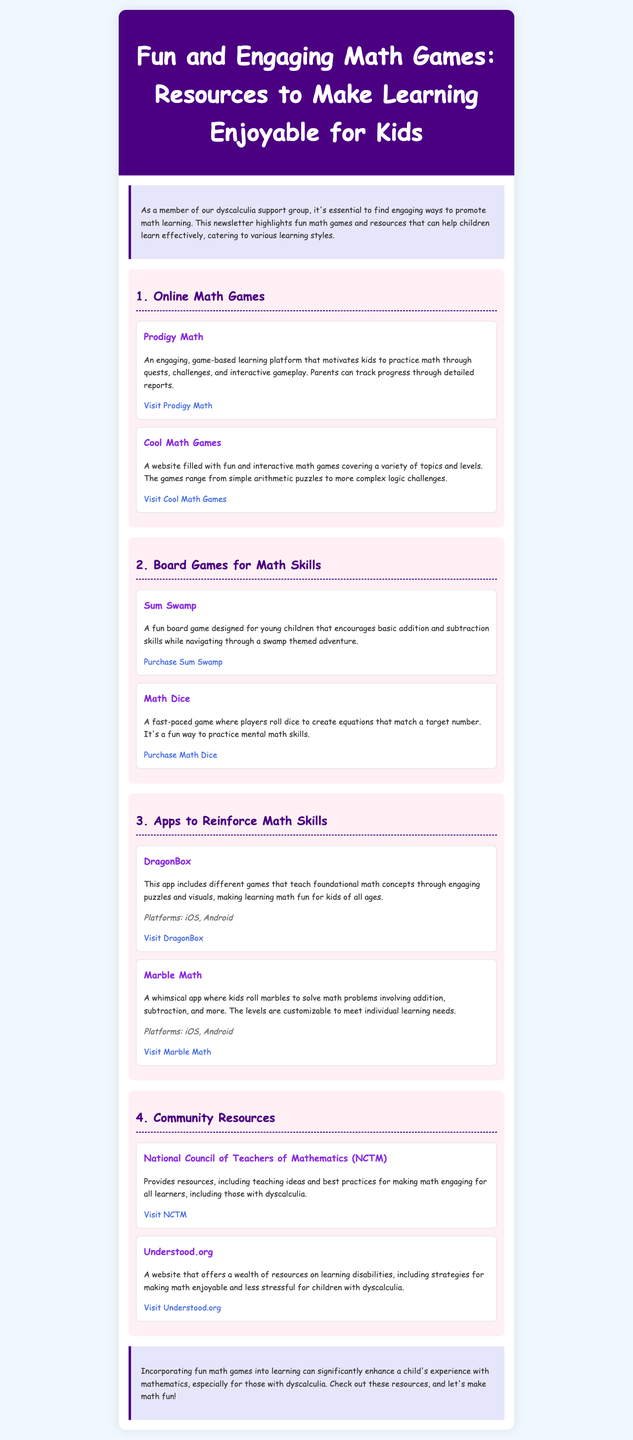what is the title of the newsletter? The title is presented prominently in the header of the document.
Answer: Fun and Engaging Math Games: Resources to Make Learning Enjoyable for Kids how many sections are in the newsletter? The structure contains multiple sections including online games, board games, apps, and community resources.
Answer: 4 name one online math game mentioned in the newsletter. Each section lists specific games, one of which is highlighted under online math games.
Answer: Prodigy Math which app focuses on teaching foundational math concepts? Specific apps are mentioned, and one is particularly noted for teaching foundational math concepts.
Answer: DragonBox what board game encourages basic addition and subtraction skills? The document lists board games and one specifically designed for teaching these skills is mentioned.
Answer: Sum Swamp what is the purpose of Understood.org? The document describes the resources provided by various organizations, detailing the purpose of Understood.org.
Answer: Strategies for making math enjoyable and less stressful for children with dyscalculia 